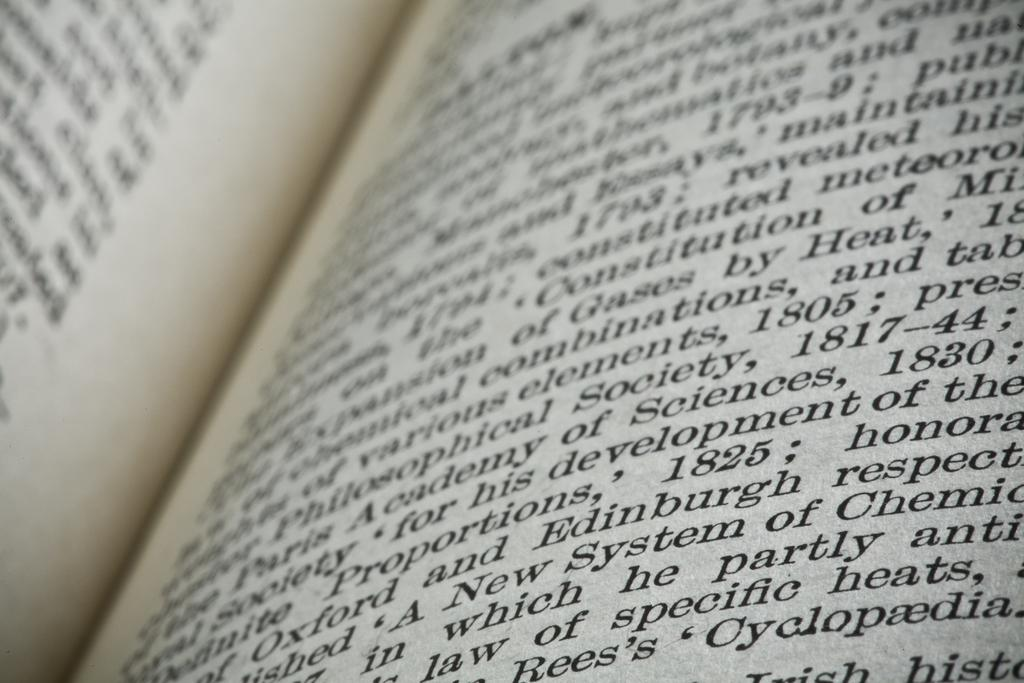Provide a one-sentence caption for the provided image. A textbook is open to a page filled with words. some of the words are about specific heats. 